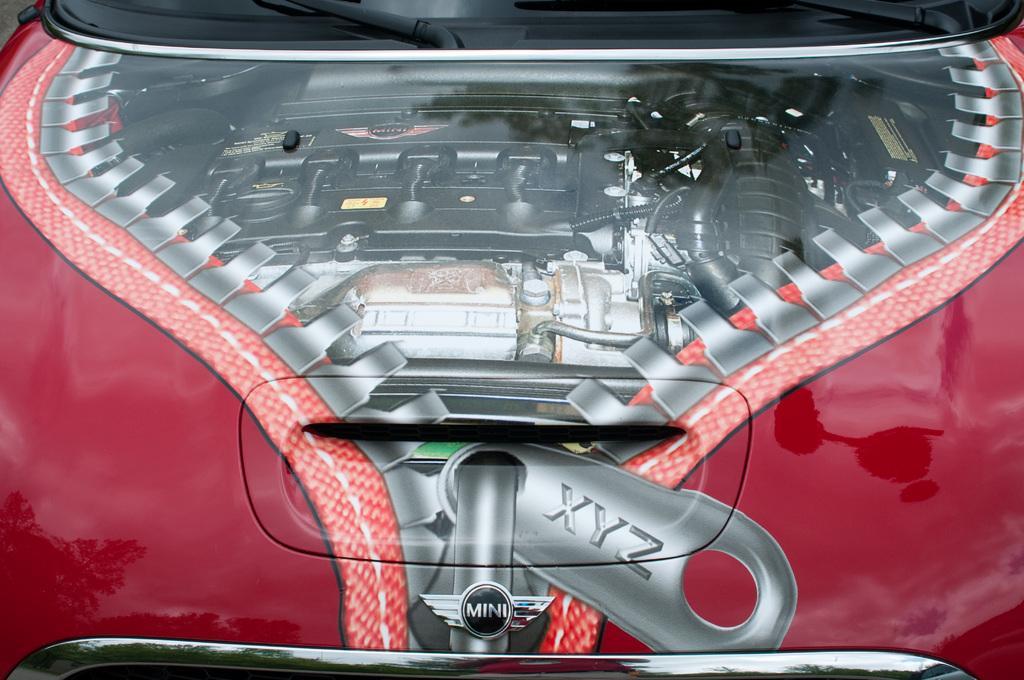In one or two sentences, can you explain what this image depicts? In this picture there is a view of the red color car bonnet with engine. In the front there is a engine head, black color turbo hose pipes. On the top there is a glass windshield with wipers. On the bottom side we can see the chrome grill and mini cooper brand logo. 